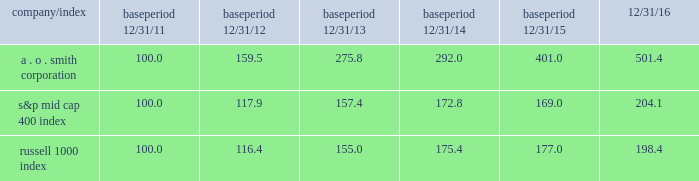The graph below shows a five-year comparison of the cumulative shareholder return on our common stock with the cumulative total return of the standard & poor 2019s ( s&p ) mid cap 400 index and the russell 1000 index , both of which are published indices .
Comparison of five-year cumulative total return from december 31 , 2011 to december 31 , 2016 assumes $ 100 invested with reinvestment of dividends period indexed returns .
2011 2012 2013 2014 2015 2016 smith ( a o ) corp s&p midcap 400 index russell 1000 index .
What was the difference in total return for the five year period ended 12/31/16 between a . o . smith corporation and the russell 1000 index? 
Computations: ((198.4 - 100) / 100)
Answer: 0.984. 